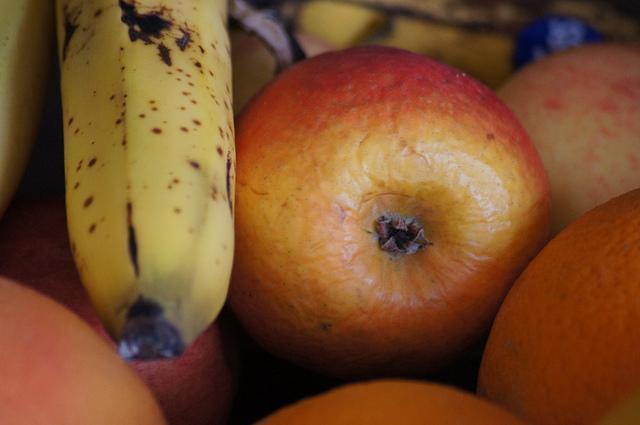What is the color of the fruit in the center of the pile?
From the following set of four choices, select the accurate answer to respond to the question.
Options: Orange, purple, blue, red. Orange. 